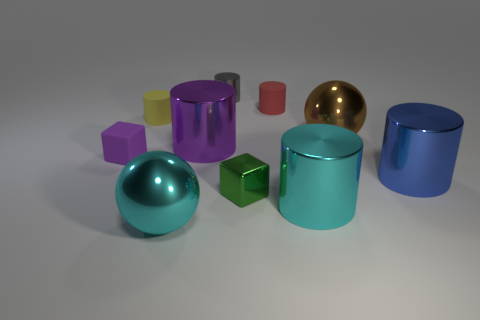Subtract all purple metallic cylinders. How many cylinders are left? 5 Subtract all purple cylinders. How many cylinders are left? 5 Subtract all gray cylinders. Subtract all gray cubes. How many cylinders are left? 5 Subtract all blocks. How many objects are left? 8 Subtract all red objects. Subtract all tiny yellow objects. How many objects are left? 8 Add 1 small green objects. How many small green objects are left? 2 Add 1 small purple things. How many small purple things exist? 2 Subtract 0 red cubes. How many objects are left? 10 